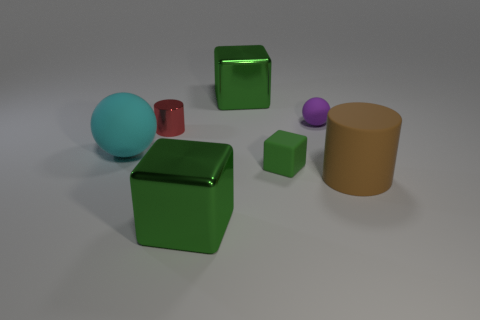Describe the texture and material appearance of the objects. The objects exhibit different textures and material appearances. The large green cube and the smaller one have a highly reflective, shiny surface, giving the impression of a smooth, possibly metallic or plastic material. The red cylinder and purple sphere have a matte finish, indicating a less reflective, possibly rougher texture. The yellow cylinder has a somewhat muted sheen, suggesting a surface that is neither overly shiny nor entirely matte, possibly a satin finish. 